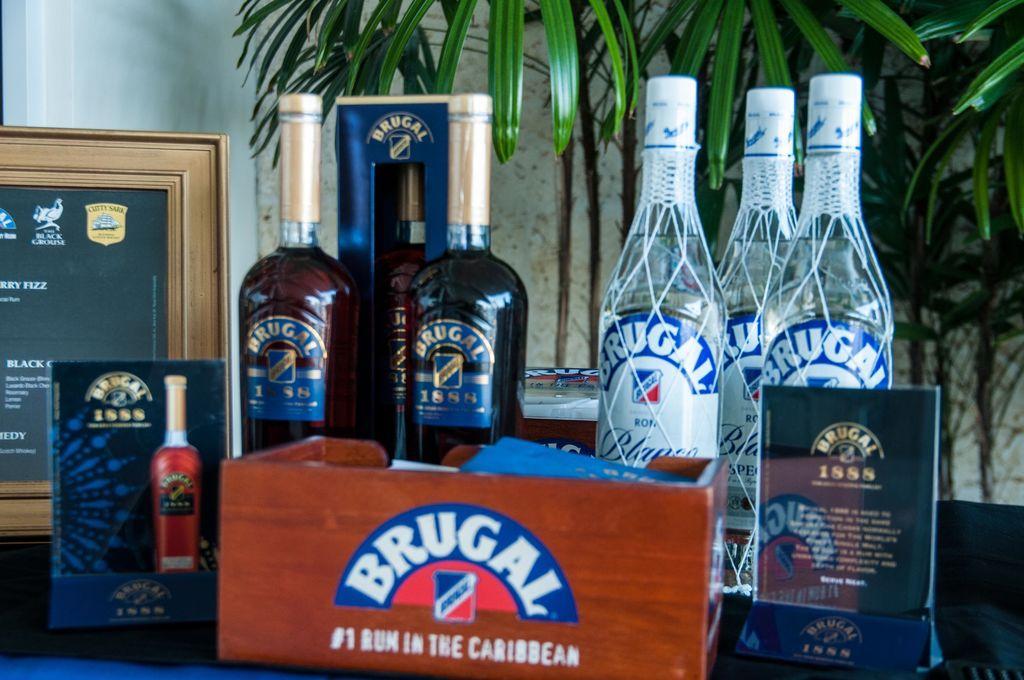How would you summarize this image in a sentence or two? In this image i can see few bottles on a table, at the back ground i can see a frame, a wall and a plant. 